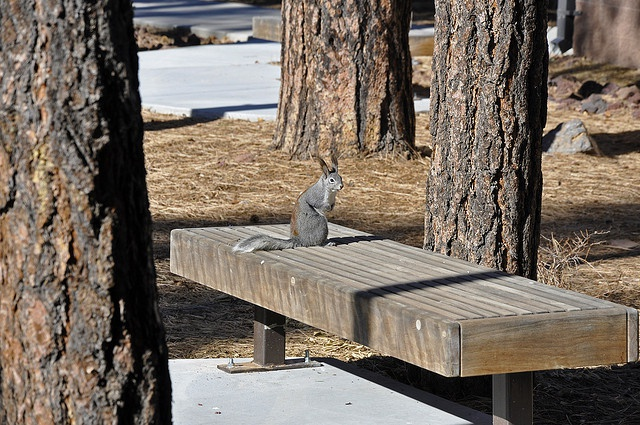Describe the objects in this image and their specific colors. I can see a bench in gray, darkgray, and black tones in this image. 